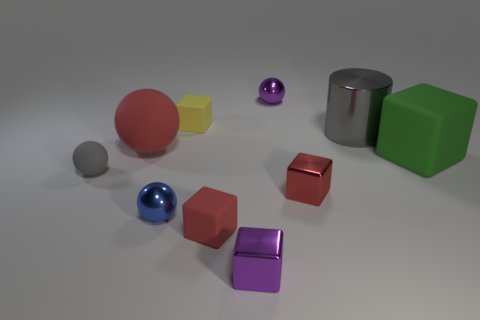What is the shape of the other object that is the same color as the big shiny thing?
Offer a terse response. Sphere. Is there any other thing that is the same size as the gray shiny cylinder?
Your answer should be compact. Yes. Is the material of the ball that is to the right of the blue ball the same as the purple block?
Make the answer very short. Yes. There is another matte object that is the same shape as the big red matte object; what is its color?
Your answer should be compact. Gray. What number of other things are there of the same color as the large shiny cylinder?
Provide a short and direct response. 1. There is a gray thing in front of the big green matte object; does it have the same shape as the tiny red thing that is in front of the blue ball?
Ensure brevity in your answer.  No. How many balls are either red objects or big purple rubber objects?
Your answer should be compact. 1. Is the number of green blocks that are on the right side of the tiny rubber sphere less than the number of large gray metal cylinders?
Offer a terse response. No. What number of other things are made of the same material as the small yellow block?
Offer a terse response. 4. Does the blue metallic sphere have the same size as the gray matte thing?
Keep it short and to the point. Yes. 